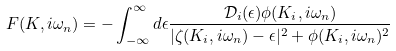Convert formula to latex. <formula><loc_0><loc_0><loc_500><loc_500>F ( K , i \omega _ { n } ) = - \int _ { - \infty } ^ { \infty } d \epsilon \frac { { \mathcal { D } } _ { i } ( \epsilon ) \phi ( K _ { i } , i \omega _ { n } ) } { | \zeta ( K _ { i } , i \omega _ { n } ) - \epsilon | ^ { 2 } + \phi ( K _ { i } , i \omega _ { n } ) ^ { 2 } }</formula> 